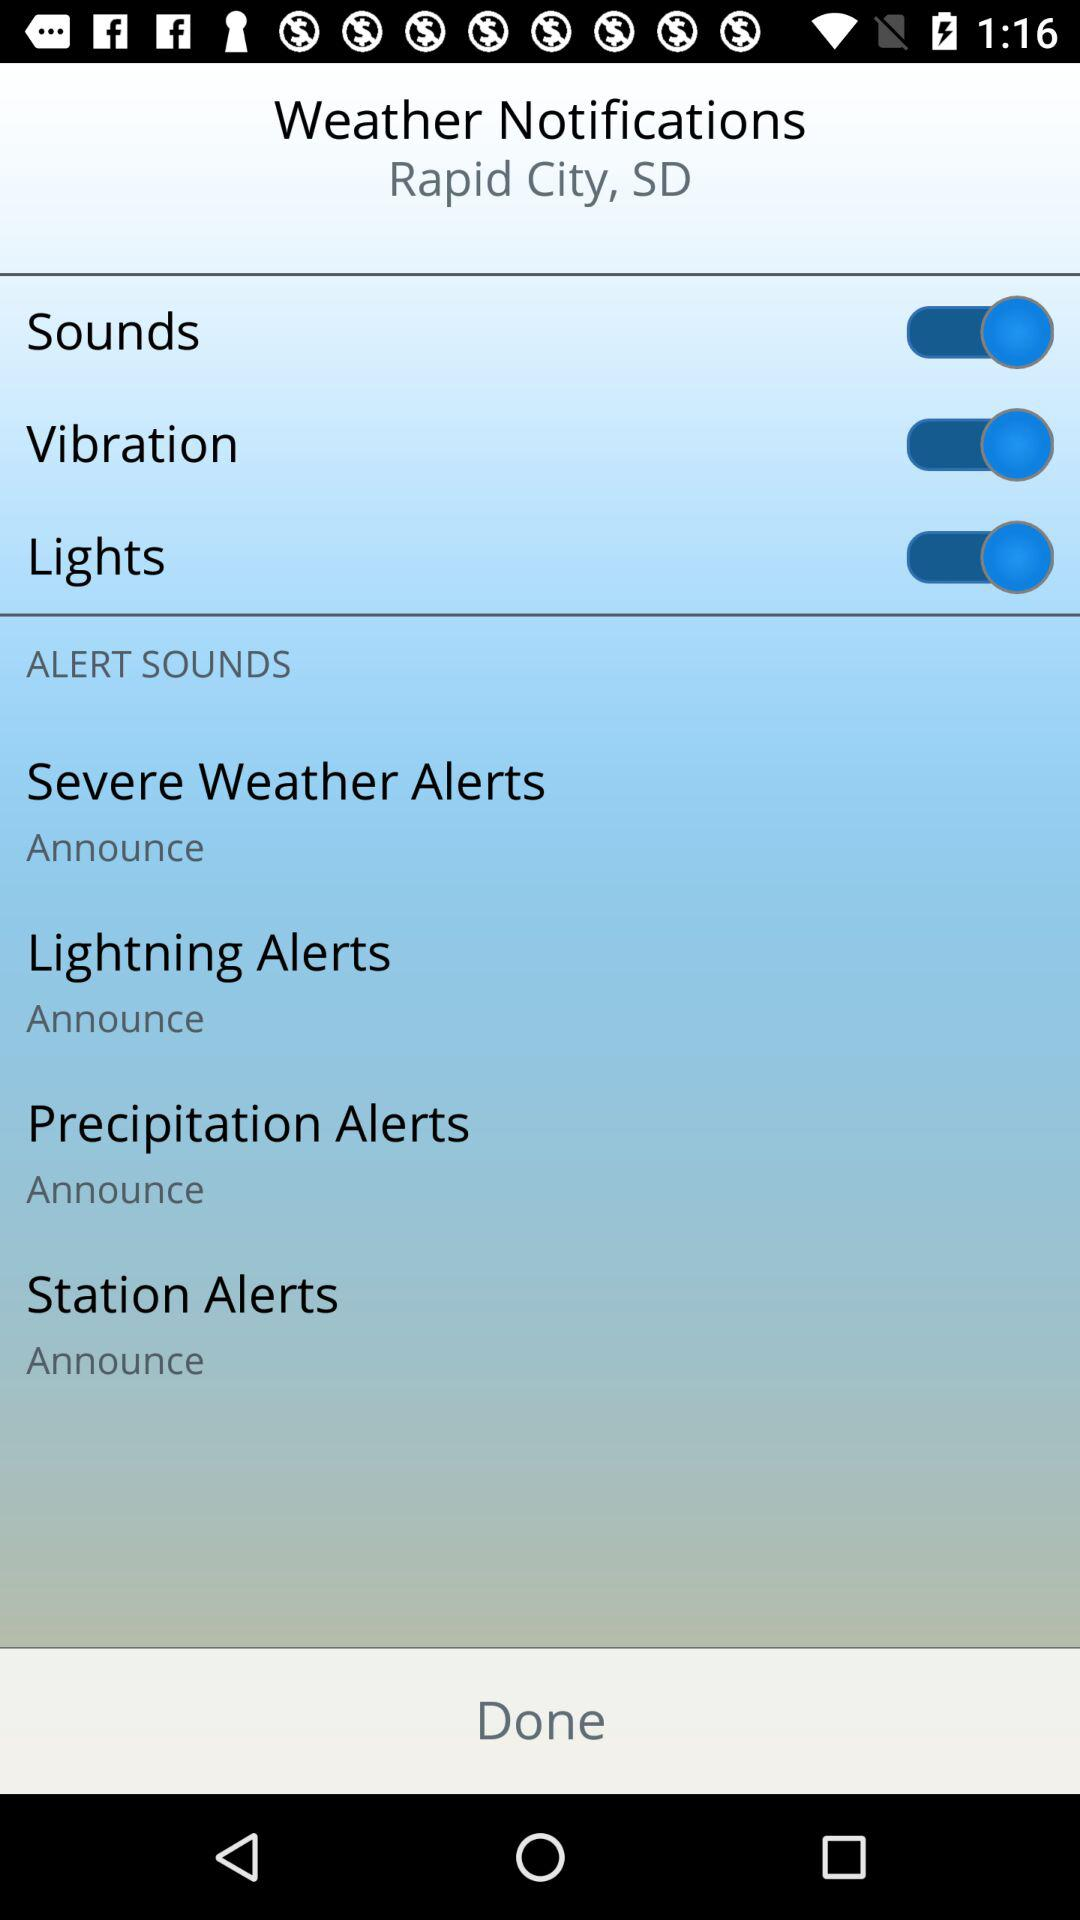How many alert sounds are there?
Answer the question using a single word or phrase. 4 